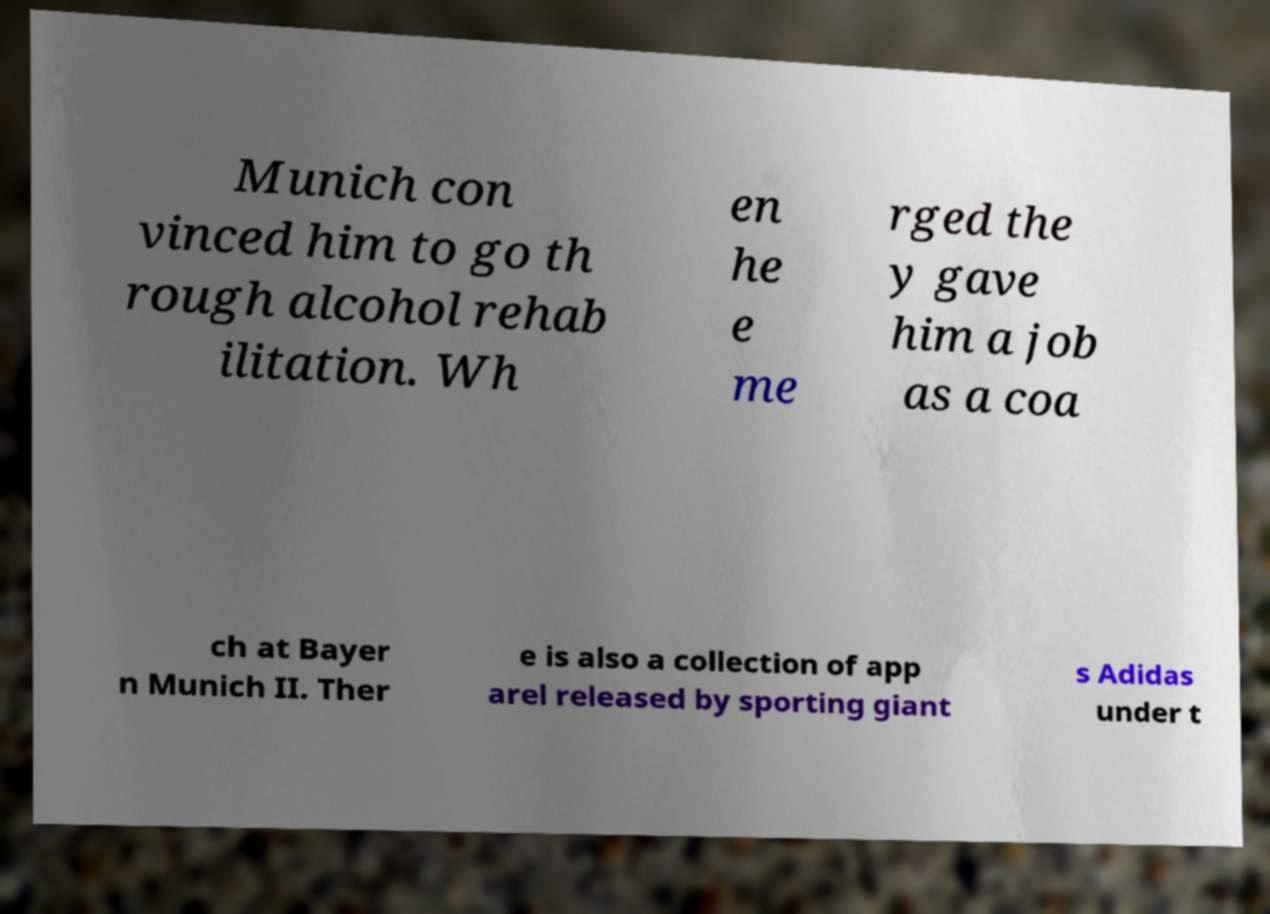Could you extract and type out the text from this image? Munich con vinced him to go th rough alcohol rehab ilitation. Wh en he e me rged the y gave him a job as a coa ch at Bayer n Munich II. Ther e is also a collection of app arel released by sporting giant s Adidas under t 